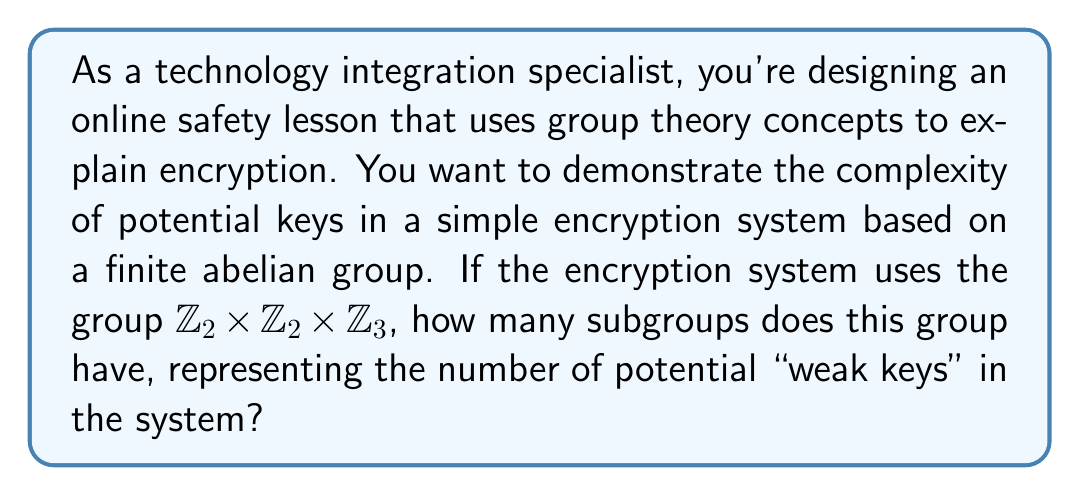Provide a solution to this math problem. To find the number of subgroups in the finite abelian group $G = \mathbb{Z}_2 \times \mathbb{Z}_2 \times \mathbb{Z}_3$, we'll follow these steps:

1) First, we need to understand the structure of the group. It's a direct product of three cyclic groups:
   $\mathbb{Z}_2$ (order 2), $\mathbb{Z}_2$ (order 2), and $\mathbb{Z}_3$ (order 3).

2) The order of G is $|G| = 2 \cdot 2 \cdot 3 = 12$.

3) To count the subgroups, we'll use the fundamental theorem of finite abelian groups. For each divisor $d$ of $|G|$, we need to count the number of subgroups of order $d$.

4) The divisors of 12 are 1, 2, 3, 4, 6, and 12.

5) Let's count the subgroups for each divisor:
   
   - Order 1: Only the trivial subgroup {0}. Count: 1
   
   - Order 2: We have three subgroups of order 2, one from each $\mathbb{Z}_2$ and one from their product. Count: 3
   
   - Order 3: One subgroup from $\mathbb{Z}_3$. Count: 1
   
   - Order 4: We can form a subgroup of order 4 by taking the product of the two $\mathbb{Z}_2$ groups. Count: 1
   
   - Order 6: We can form two subgroups of order 6 by taking the product of $\mathbb{Z}_3$ with either of the $\mathbb{Z}_2$ groups. Count: 2
   
   - Order 12: The entire group G. Count: 1

6) The total number of subgroups is the sum of all these counts:
   $1 + 3 + 1 + 1 + 2 + 1 = 9$

Therefore, the group $\mathbb{Z}_2 \times \mathbb{Z}_2 \times \mathbb{Z}_3$ has 9 subgroups.
Answer: The group $\mathbb{Z}_2 \times \mathbb{Z}_2 \times \mathbb{Z}_3$ has 9 subgroups. 